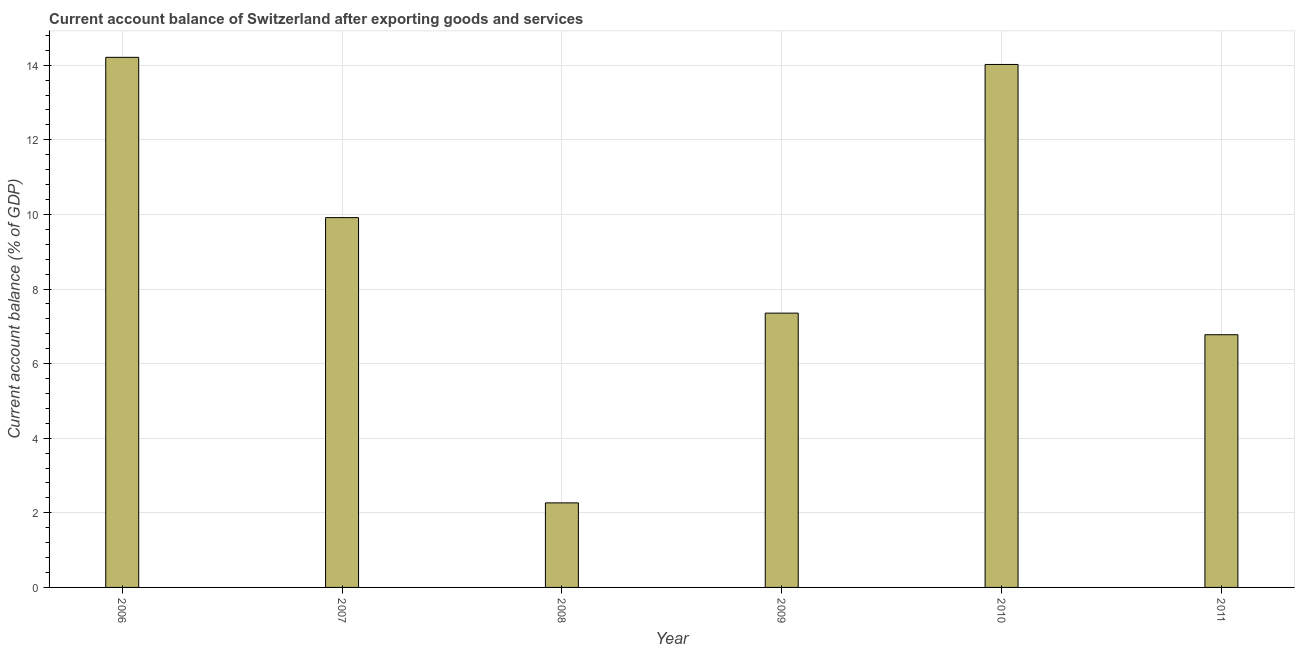Does the graph contain any zero values?
Provide a succinct answer. No. What is the title of the graph?
Your answer should be compact. Current account balance of Switzerland after exporting goods and services. What is the label or title of the X-axis?
Provide a short and direct response. Year. What is the label or title of the Y-axis?
Offer a very short reply. Current account balance (% of GDP). What is the current account balance in 2009?
Keep it short and to the point. 7.35. Across all years, what is the maximum current account balance?
Keep it short and to the point. 14.21. Across all years, what is the minimum current account balance?
Your answer should be very brief. 2.27. In which year was the current account balance maximum?
Provide a succinct answer. 2006. What is the sum of the current account balance?
Your answer should be compact. 54.54. What is the difference between the current account balance in 2009 and 2011?
Keep it short and to the point. 0.58. What is the average current account balance per year?
Ensure brevity in your answer.  9.09. What is the median current account balance?
Ensure brevity in your answer.  8.63. In how many years, is the current account balance greater than 8 %?
Keep it short and to the point. 3. Do a majority of the years between 2008 and 2009 (inclusive) have current account balance greater than 8.8 %?
Give a very brief answer. No. What is the ratio of the current account balance in 2008 to that in 2011?
Provide a succinct answer. 0.34. Is the difference between the current account balance in 2008 and 2010 greater than the difference between any two years?
Offer a very short reply. No. What is the difference between the highest and the second highest current account balance?
Make the answer very short. 0.19. What is the difference between the highest and the lowest current account balance?
Your response must be concise. 11.94. In how many years, is the current account balance greater than the average current account balance taken over all years?
Your answer should be compact. 3. How many bars are there?
Ensure brevity in your answer.  6. Are all the bars in the graph horizontal?
Keep it short and to the point. No. What is the difference between two consecutive major ticks on the Y-axis?
Keep it short and to the point. 2. What is the Current account balance (% of GDP) in 2006?
Provide a short and direct response. 14.21. What is the Current account balance (% of GDP) in 2007?
Ensure brevity in your answer.  9.91. What is the Current account balance (% of GDP) in 2008?
Your answer should be very brief. 2.27. What is the Current account balance (% of GDP) in 2009?
Offer a very short reply. 7.35. What is the Current account balance (% of GDP) of 2010?
Keep it short and to the point. 14.02. What is the Current account balance (% of GDP) in 2011?
Ensure brevity in your answer.  6.77. What is the difference between the Current account balance (% of GDP) in 2006 and 2007?
Provide a succinct answer. 4.3. What is the difference between the Current account balance (% of GDP) in 2006 and 2008?
Give a very brief answer. 11.94. What is the difference between the Current account balance (% of GDP) in 2006 and 2009?
Offer a terse response. 6.86. What is the difference between the Current account balance (% of GDP) in 2006 and 2010?
Your answer should be compact. 0.19. What is the difference between the Current account balance (% of GDP) in 2006 and 2011?
Provide a succinct answer. 7.44. What is the difference between the Current account balance (% of GDP) in 2007 and 2008?
Provide a short and direct response. 7.65. What is the difference between the Current account balance (% of GDP) in 2007 and 2009?
Your answer should be compact. 2.56. What is the difference between the Current account balance (% of GDP) in 2007 and 2010?
Offer a terse response. -4.11. What is the difference between the Current account balance (% of GDP) in 2007 and 2011?
Your answer should be compact. 3.14. What is the difference between the Current account balance (% of GDP) in 2008 and 2009?
Make the answer very short. -5.09. What is the difference between the Current account balance (% of GDP) in 2008 and 2010?
Provide a short and direct response. -11.75. What is the difference between the Current account balance (% of GDP) in 2008 and 2011?
Offer a terse response. -4.51. What is the difference between the Current account balance (% of GDP) in 2009 and 2010?
Your answer should be very brief. -6.67. What is the difference between the Current account balance (% of GDP) in 2009 and 2011?
Ensure brevity in your answer.  0.58. What is the difference between the Current account balance (% of GDP) in 2010 and 2011?
Provide a succinct answer. 7.25. What is the ratio of the Current account balance (% of GDP) in 2006 to that in 2007?
Make the answer very short. 1.43. What is the ratio of the Current account balance (% of GDP) in 2006 to that in 2008?
Give a very brief answer. 6.27. What is the ratio of the Current account balance (% of GDP) in 2006 to that in 2009?
Make the answer very short. 1.93. What is the ratio of the Current account balance (% of GDP) in 2006 to that in 2011?
Keep it short and to the point. 2.1. What is the ratio of the Current account balance (% of GDP) in 2007 to that in 2008?
Your response must be concise. 4.37. What is the ratio of the Current account balance (% of GDP) in 2007 to that in 2009?
Keep it short and to the point. 1.35. What is the ratio of the Current account balance (% of GDP) in 2007 to that in 2010?
Offer a terse response. 0.71. What is the ratio of the Current account balance (% of GDP) in 2007 to that in 2011?
Offer a very short reply. 1.46. What is the ratio of the Current account balance (% of GDP) in 2008 to that in 2009?
Make the answer very short. 0.31. What is the ratio of the Current account balance (% of GDP) in 2008 to that in 2010?
Your answer should be very brief. 0.16. What is the ratio of the Current account balance (% of GDP) in 2008 to that in 2011?
Your answer should be very brief. 0.34. What is the ratio of the Current account balance (% of GDP) in 2009 to that in 2010?
Make the answer very short. 0.53. What is the ratio of the Current account balance (% of GDP) in 2009 to that in 2011?
Make the answer very short. 1.08. What is the ratio of the Current account balance (% of GDP) in 2010 to that in 2011?
Offer a very short reply. 2.07. 